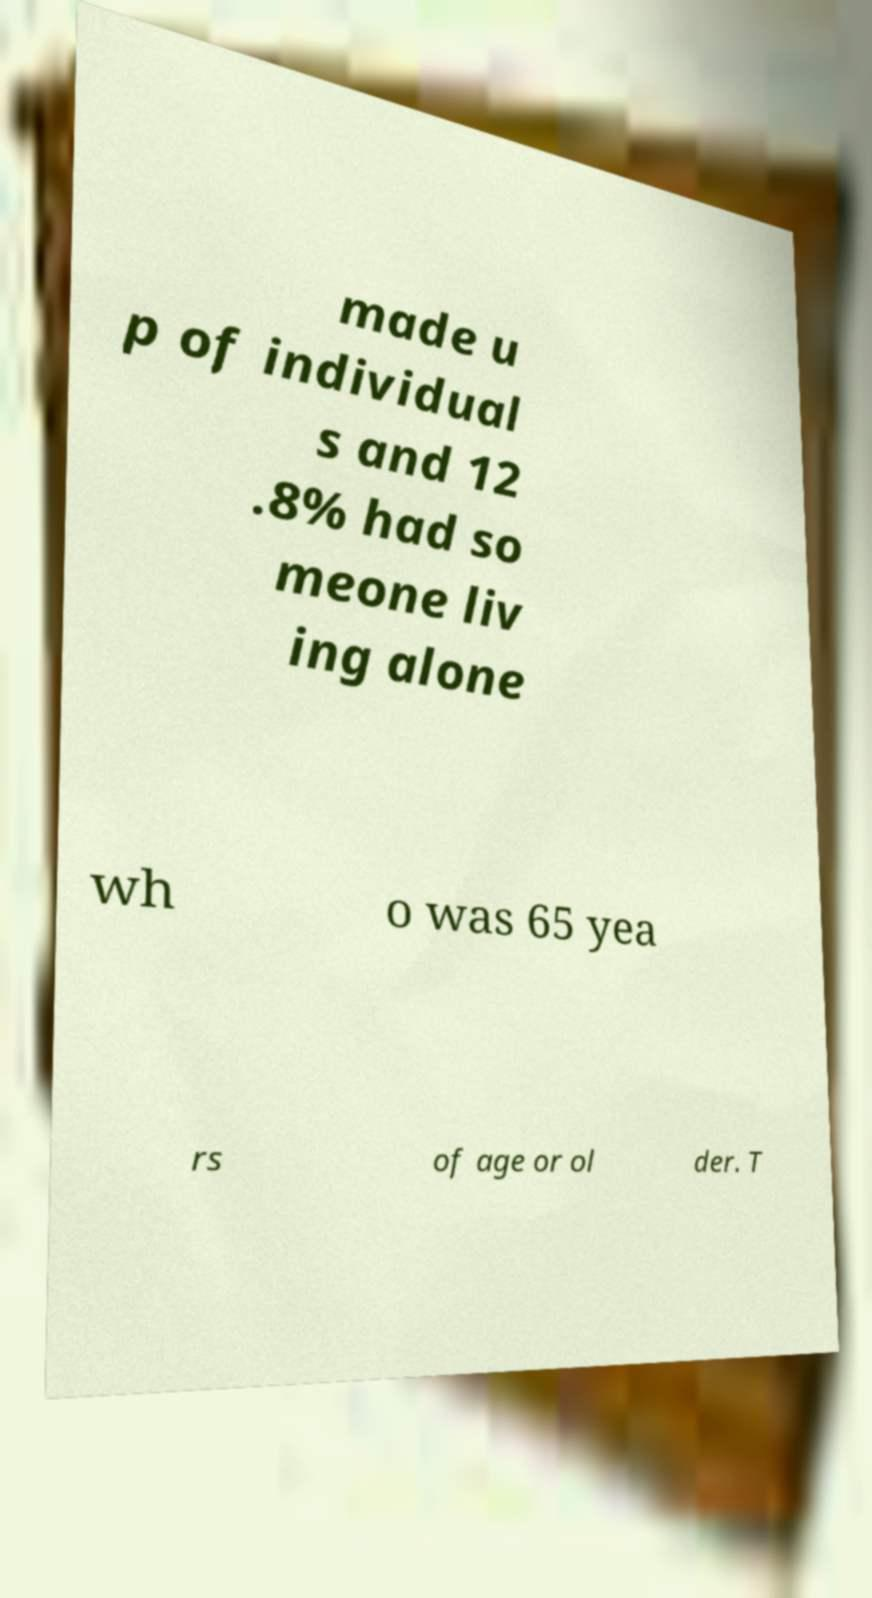Can you accurately transcribe the text from the provided image for me? made u p of individual s and 12 .8% had so meone liv ing alone wh o was 65 yea rs of age or ol der. T 